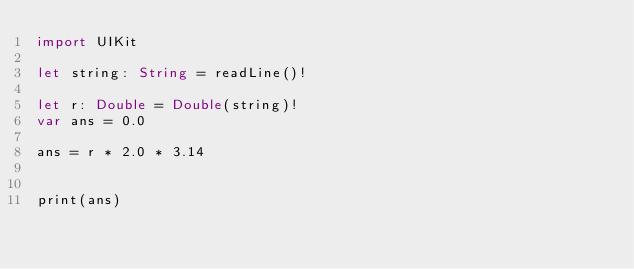Convert code to text. <code><loc_0><loc_0><loc_500><loc_500><_Swift_>import UIKit

let string: String = readLine()!
 
let r: Double = Double(string)!
var ans = 0.0

ans = r * 2.0 * 3.14
 

print(ans)</code> 